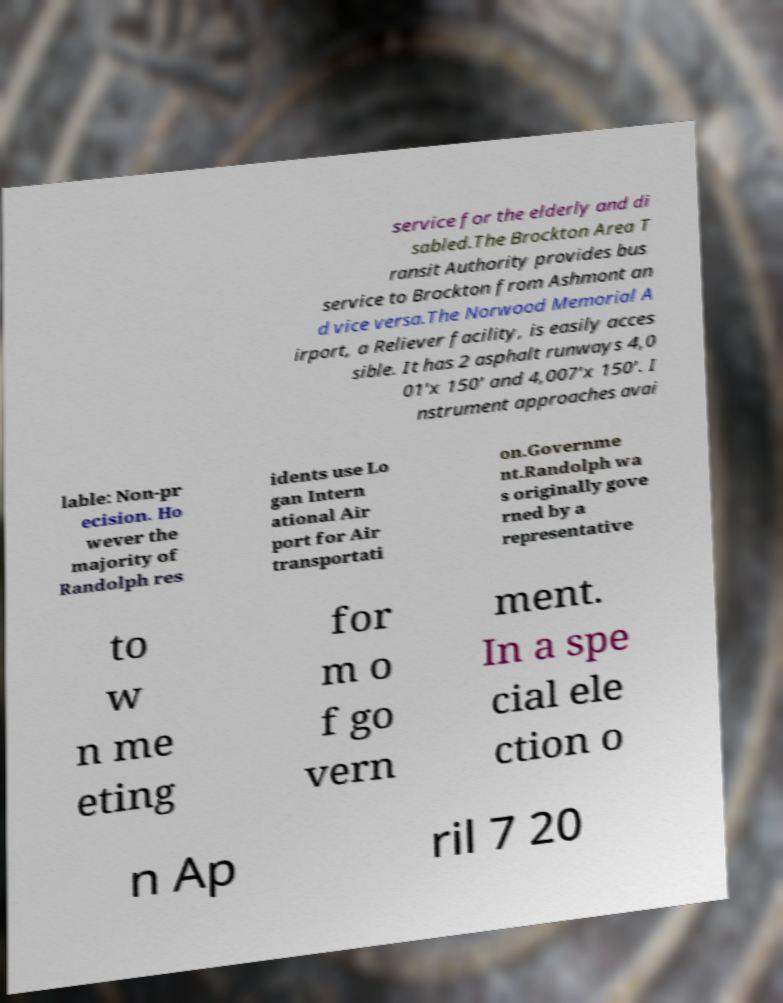Could you extract and type out the text from this image? service for the elderly and di sabled.The Brockton Area T ransit Authority provides bus service to Brockton from Ashmont an d vice versa.The Norwood Memorial A irport, a Reliever facility, is easily acces sible. It has 2 asphalt runways 4,0 01'x 150' and 4,007'x 150'. I nstrument approaches avai lable: Non-pr ecision. Ho wever the majority of Randolph res idents use Lo gan Intern ational Air port for Air transportati on.Governme nt.Randolph wa s originally gove rned by a representative to w n me eting for m o f go vern ment. In a spe cial ele ction o n Ap ril 7 20 